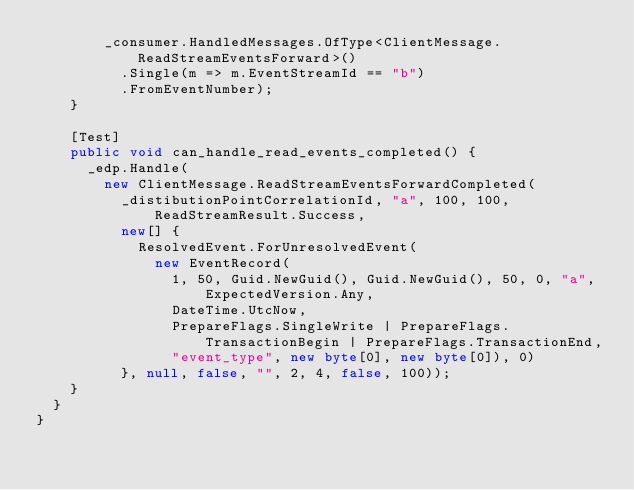Convert code to text. <code><loc_0><loc_0><loc_500><loc_500><_C#_>				_consumer.HandledMessages.OfType<ClientMessage.ReadStreamEventsForward>()
					.Single(m => m.EventStreamId == "b")
					.FromEventNumber);
		}

		[Test]
		public void can_handle_read_events_completed() {
			_edp.Handle(
				new ClientMessage.ReadStreamEventsForwardCompleted(
					_distibutionPointCorrelationId, "a", 100, 100, ReadStreamResult.Success,
					new[] {
						ResolvedEvent.ForUnresolvedEvent(
							new EventRecord(
								1, 50, Guid.NewGuid(), Guid.NewGuid(), 50, 0, "a", ExpectedVersion.Any,
								DateTime.UtcNow,
								PrepareFlags.SingleWrite | PrepareFlags.TransactionBegin | PrepareFlags.TransactionEnd,
								"event_type", new byte[0], new byte[0]), 0)
					}, null, false, "", 2, 4, false, 100));
		}
	}
}
</code> 